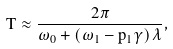<formula> <loc_0><loc_0><loc_500><loc_500>T \approx \frac { 2 \pi } { \omega _ { 0 } + \left ( \omega _ { 1 } - p _ { 1 } \gamma \right ) \lambda } ,</formula> 